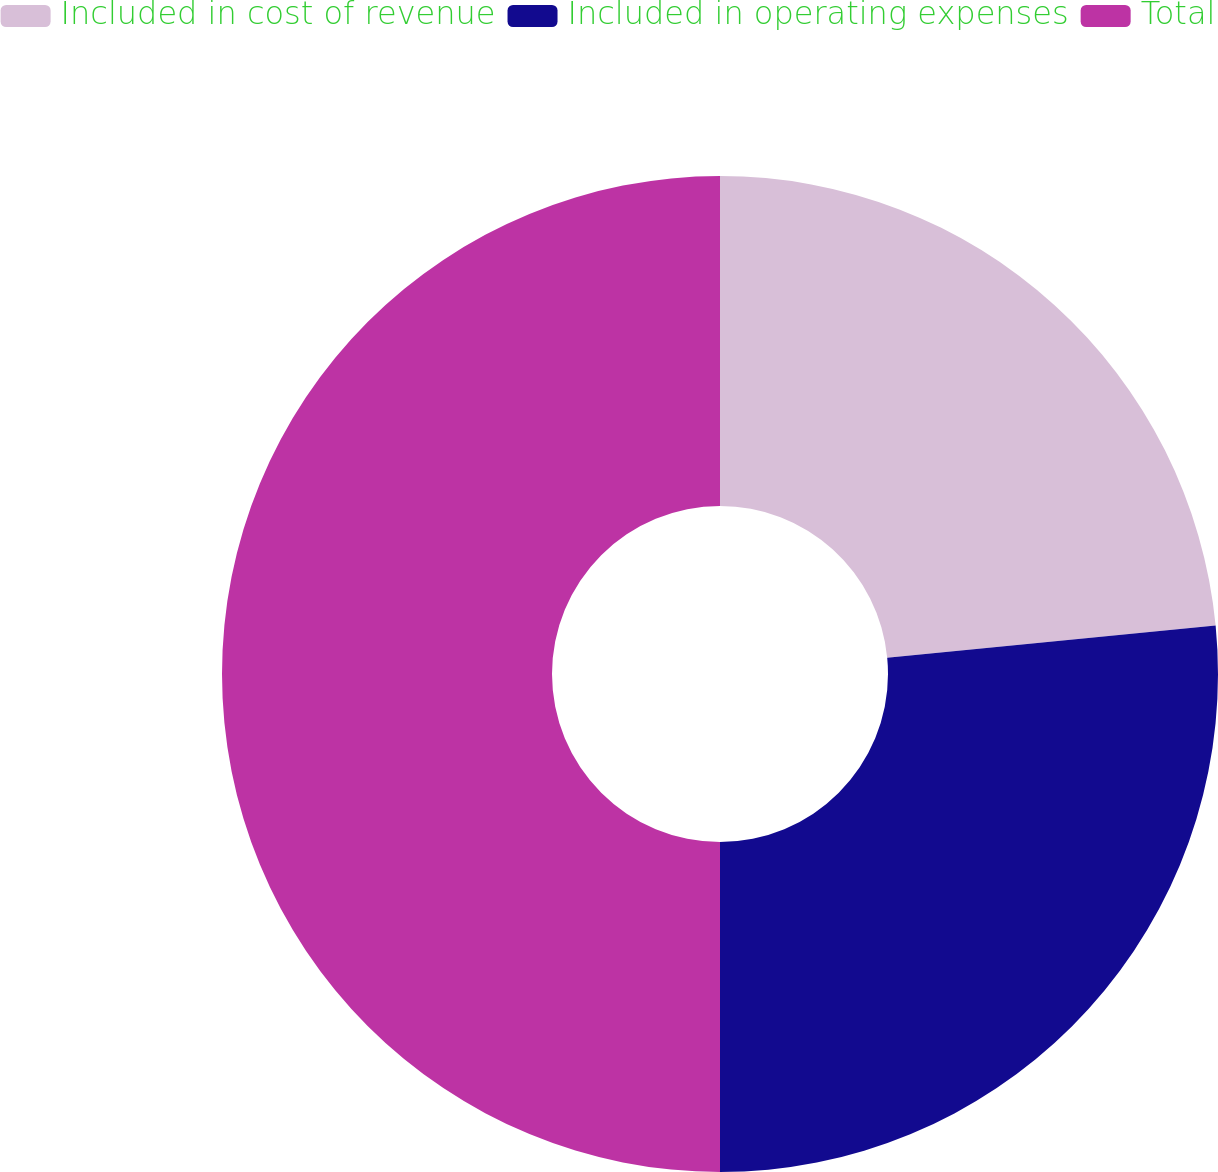Convert chart. <chart><loc_0><loc_0><loc_500><loc_500><pie_chart><fcel>Included in cost of revenue<fcel>Included in operating expenses<fcel>Total<nl><fcel>23.45%<fcel>26.55%<fcel>50.0%<nl></chart> 